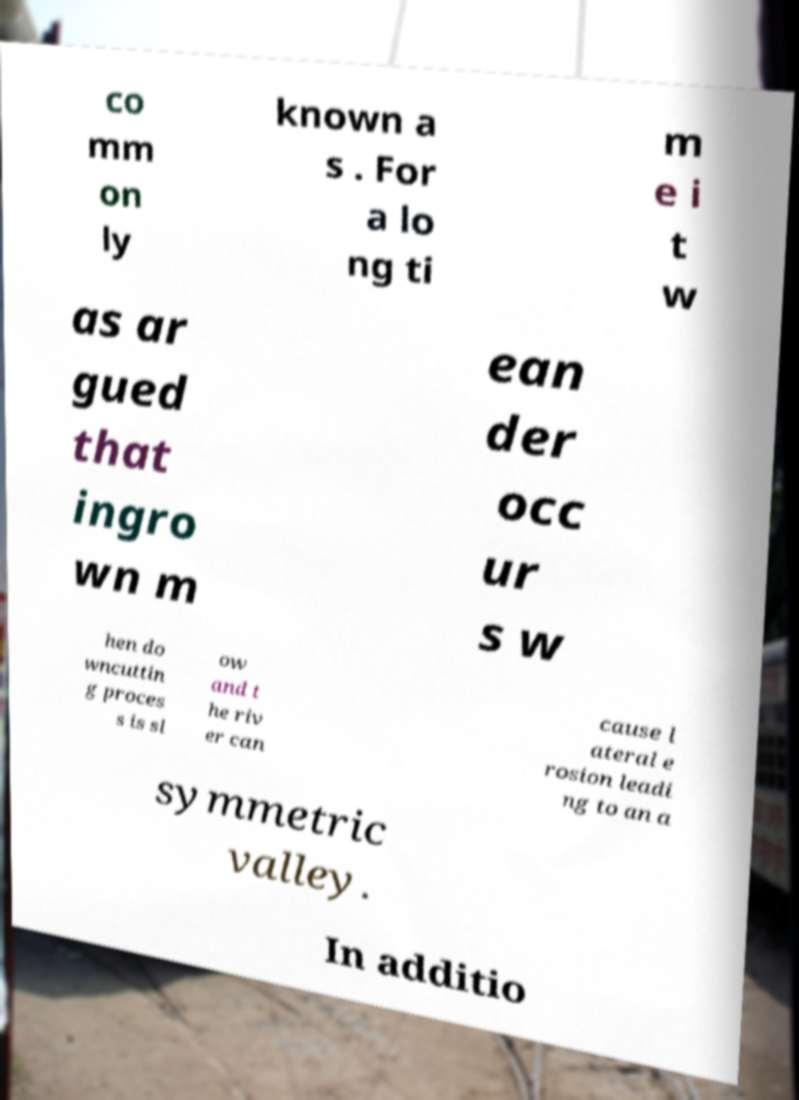Please identify and transcribe the text found in this image. co mm on ly known a s . For a lo ng ti m e i t w as ar gued that ingro wn m ean der occ ur s w hen do wncuttin g proces s is sl ow and t he riv er can cause l ateral e rosion leadi ng to an a symmetric valley. In additio 